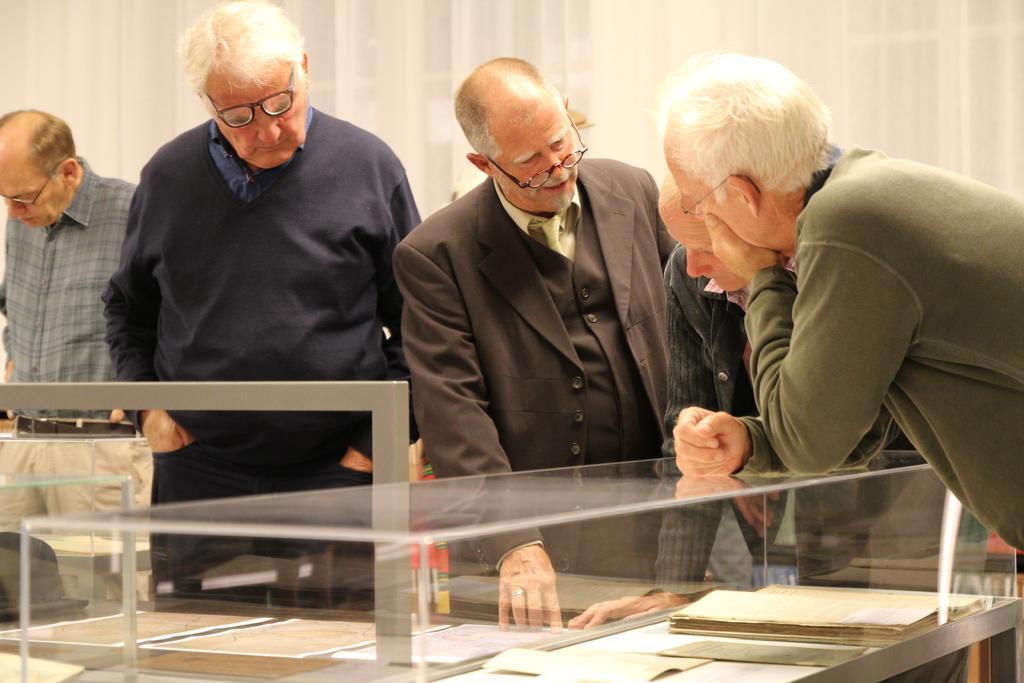In one or two sentences, can you explain what this image depicts? In this image, we can see few people. At the bottom, we can see a table, few papers, book are placed on it. Here there is a glass and rod. Background we can see white color. 